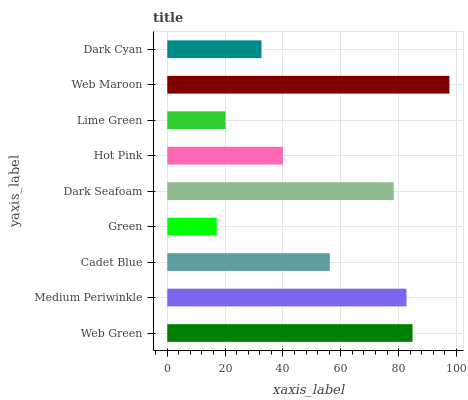Is Green the minimum?
Answer yes or no. Yes. Is Web Maroon the maximum?
Answer yes or no. Yes. Is Medium Periwinkle the minimum?
Answer yes or no. No. Is Medium Periwinkle the maximum?
Answer yes or no. No. Is Web Green greater than Medium Periwinkle?
Answer yes or no. Yes. Is Medium Periwinkle less than Web Green?
Answer yes or no. Yes. Is Medium Periwinkle greater than Web Green?
Answer yes or no. No. Is Web Green less than Medium Periwinkle?
Answer yes or no. No. Is Cadet Blue the high median?
Answer yes or no. Yes. Is Cadet Blue the low median?
Answer yes or no. Yes. Is Lime Green the high median?
Answer yes or no. No. Is Web Maroon the low median?
Answer yes or no. No. 